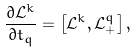<formula> <loc_0><loc_0><loc_500><loc_500>\frac { \partial { \mathcal { L } } ^ { k } } { \partial t _ { q } } = \left [ { \mathcal { L } } ^ { k } , { \mathcal { L } } _ { + } ^ { q } \right ] ,</formula> 